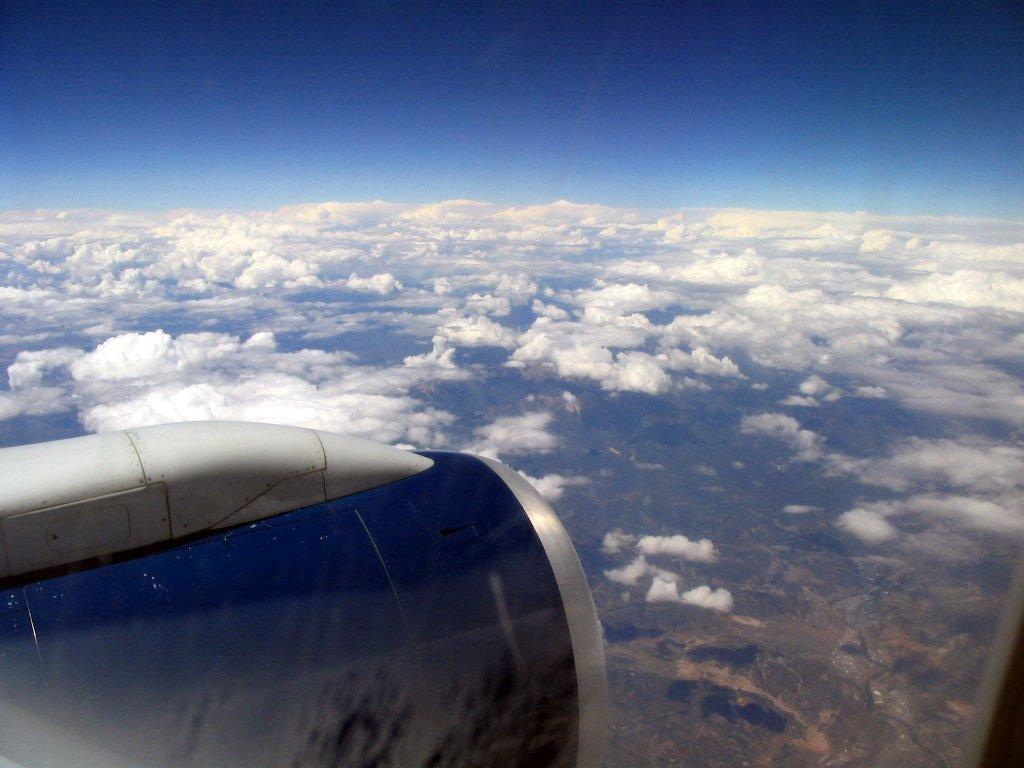What is the main subject of the picture? The main subject of the picture is an airplane. What can be seen in the sky in the picture? There are clouds visible in the picture. What type of shoes can be seen on the airplane in the image? There are no shoes present on the airplane in the image. What type of stew is being served on the airplane in the image? There is no stew present on the airplane in the image. 